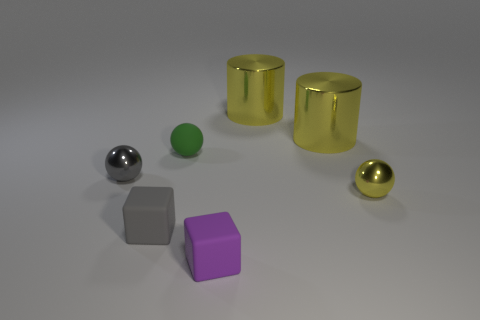Is the number of tiny metallic things greater than the number of tiny gray spheres?
Ensure brevity in your answer.  Yes. Does the tiny gray ball have the same material as the yellow thing in front of the small matte ball?
Your answer should be compact. Yes. What number of objects are either yellow metallic objects or rubber cubes?
Make the answer very short. 5. Do the metal thing that is in front of the gray shiny ball and the shiny ball that is behind the yellow sphere have the same size?
Make the answer very short. Yes. What number of blocks are metal objects or matte objects?
Your answer should be compact. 2. Are there any yellow things?
Your response must be concise. Yes. Is there anything else that has the same shape as the tiny gray shiny object?
Offer a terse response. Yes. What number of things are small gray balls left of the yellow metallic ball or tiny blue metallic cylinders?
Ensure brevity in your answer.  1. There is a small metallic sphere that is left of the cube behind the small purple thing; what number of tiny purple rubber things are to the left of it?
Give a very brief answer. 0. The matte thing to the left of the rubber object behind the gray thing that is in front of the tiny yellow metallic sphere is what shape?
Make the answer very short. Cube. 